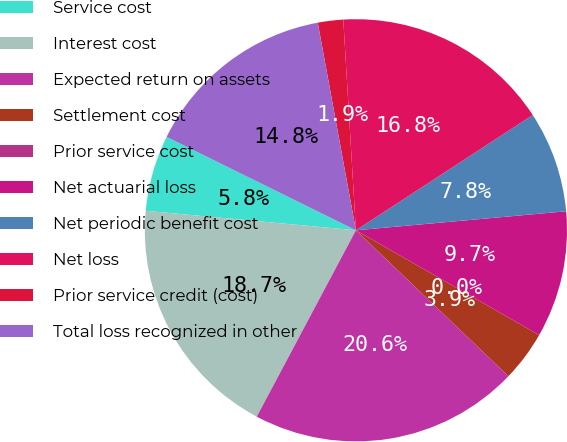<chart> <loc_0><loc_0><loc_500><loc_500><pie_chart><fcel>Service cost<fcel>Interest cost<fcel>Expected return on assets<fcel>Settlement cost<fcel>Prior service cost<fcel>Net actuarial loss<fcel>Net periodic benefit cost<fcel>Net loss<fcel>Prior service credit (cost)<fcel>Total loss recognized in other<nl><fcel>5.82%<fcel>18.69%<fcel>20.63%<fcel>3.88%<fcel>0.0%<fcel>9.7%<fcel>7.76%<fcel>16.75%<fcel>1.94%<fcel>14.81%<nl></chart> 